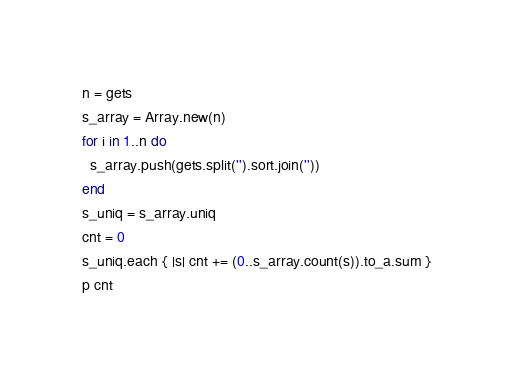Convert code to text. <code><loc_0><loc_0><loc_500><loc_500><_Ruby_>n = gets
s_array = Array.new(n)
for i in 1..n do
  s_array.push(gets.split('').sort.join(''))
end
s_uniq = s_array.uniq
cnt = 0
s_uniq.each { |s| cnt += (0..s_array.count(s)).to_a.sum }
p cnt
</code> 